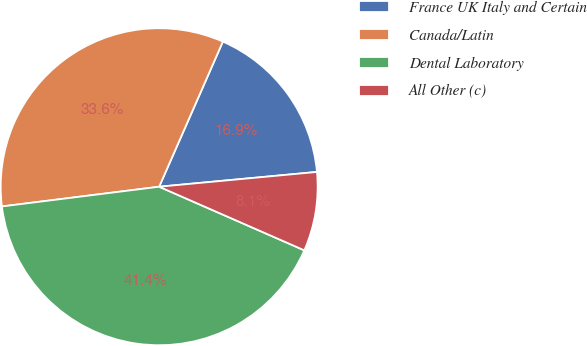Convert chart to OTSL. <chart><loc_0><loc_0><loc_500><loc_500><pie_chart><fcel>France UK Italy and Certain<fcel>Canada/Latin<fcel>Dental Laboratory<fcel>All Other (c)<nl><fcel>16.93%<fcel>33.57%<fcel>41.44%<fcel>8.06%<nl></chart> 